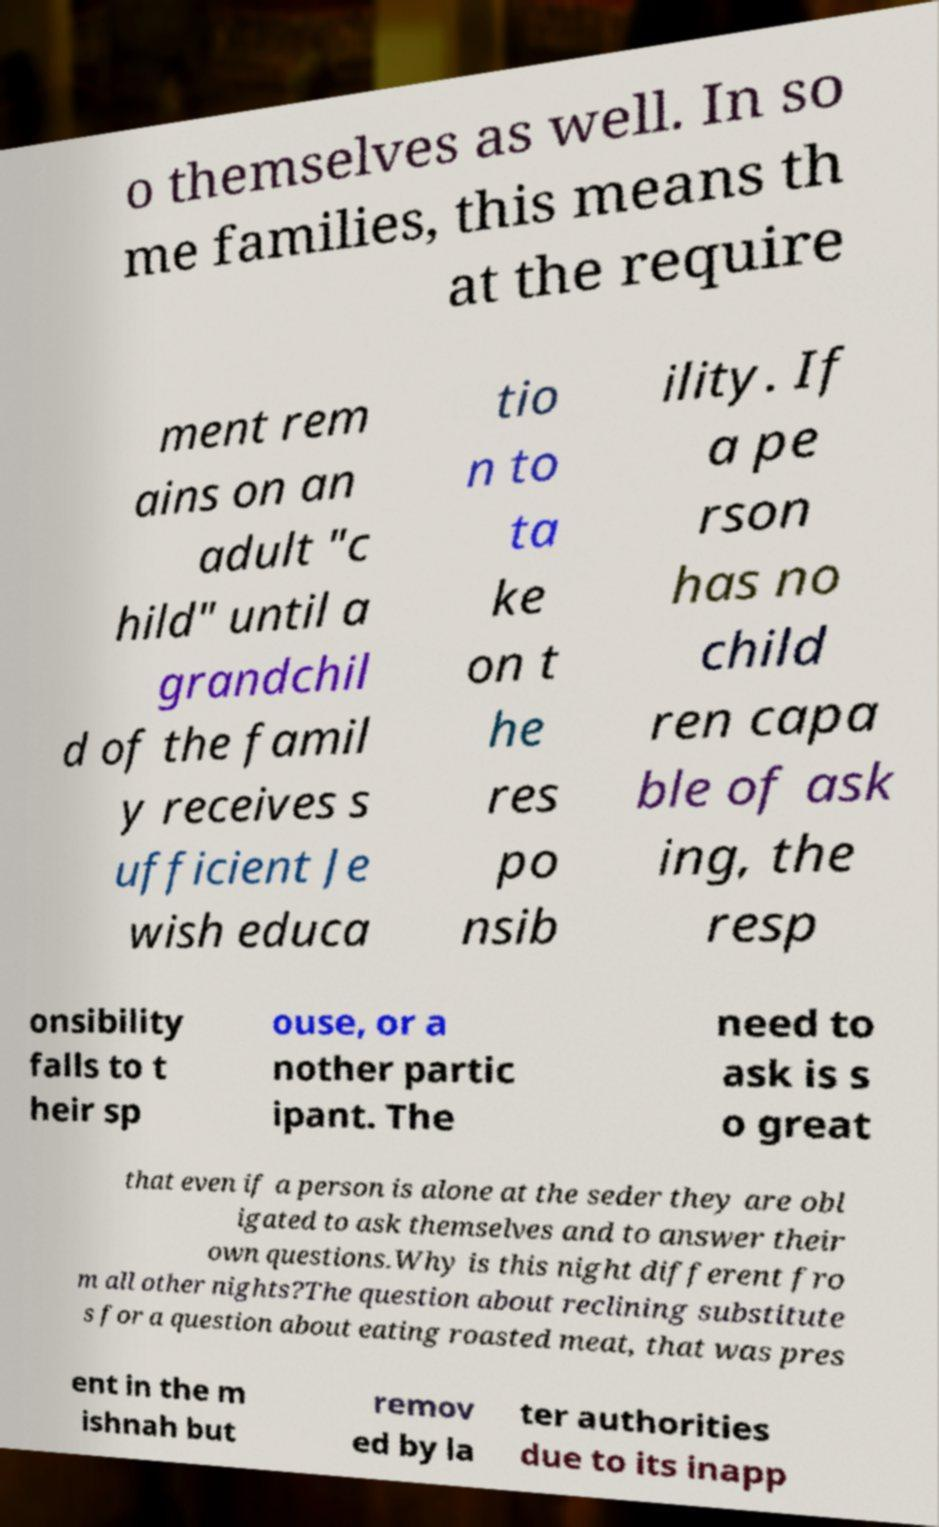Could you assist in decoding the text presented in this image and type it out clearly? o themselves as well. In so me families, this means th at the require ment rem ains on an adult "c hild" until a grandchil d of the famil y receives s ufficient Je wish educa tio n to ta ke on t he res po nsib ility. If a pe rson has no child ren capa ble of ask ing, the resp onsibility falls to t heir sp ouse, or a nother partic ipant. The need to ask is s o great that even if a person is alone at the seder they are obl igated to ask themselves and to answer their own questions.Why is this night different fro m all other nights?The question about reclining substitute s for a question about eating roasted meat, that was pres ent in the m ishnah but remov ed by la ter authorities due to its inapp 